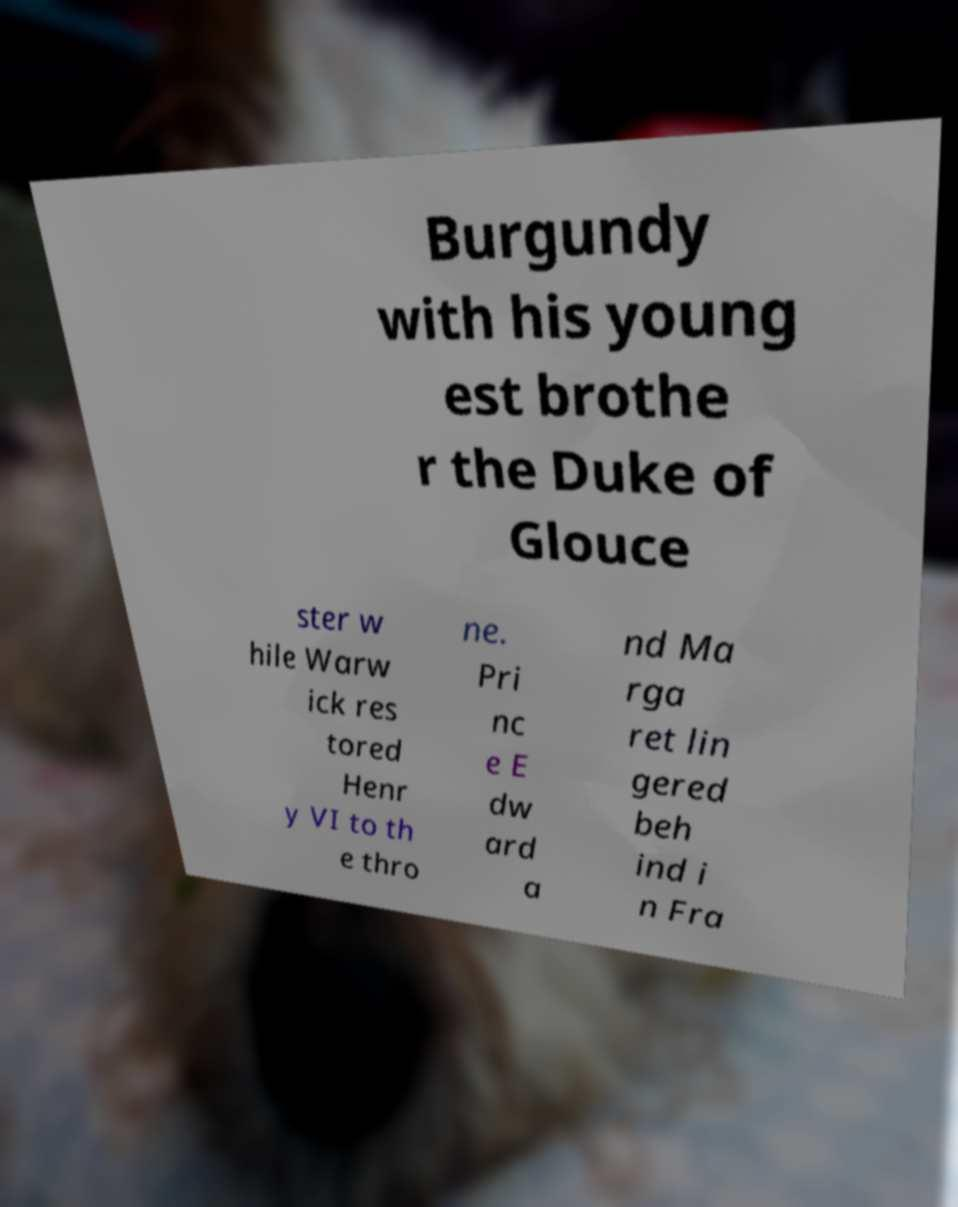Can you accurately transcribe the text from the provided image for me? Burgundy with his young est brothe r the Duke of Glouce ster w hile Warw ick res tored Henr y VI to th e thro ne. Pri nc e E dw ard a nd Ma rga ret lin gered beh ind i n Fra 